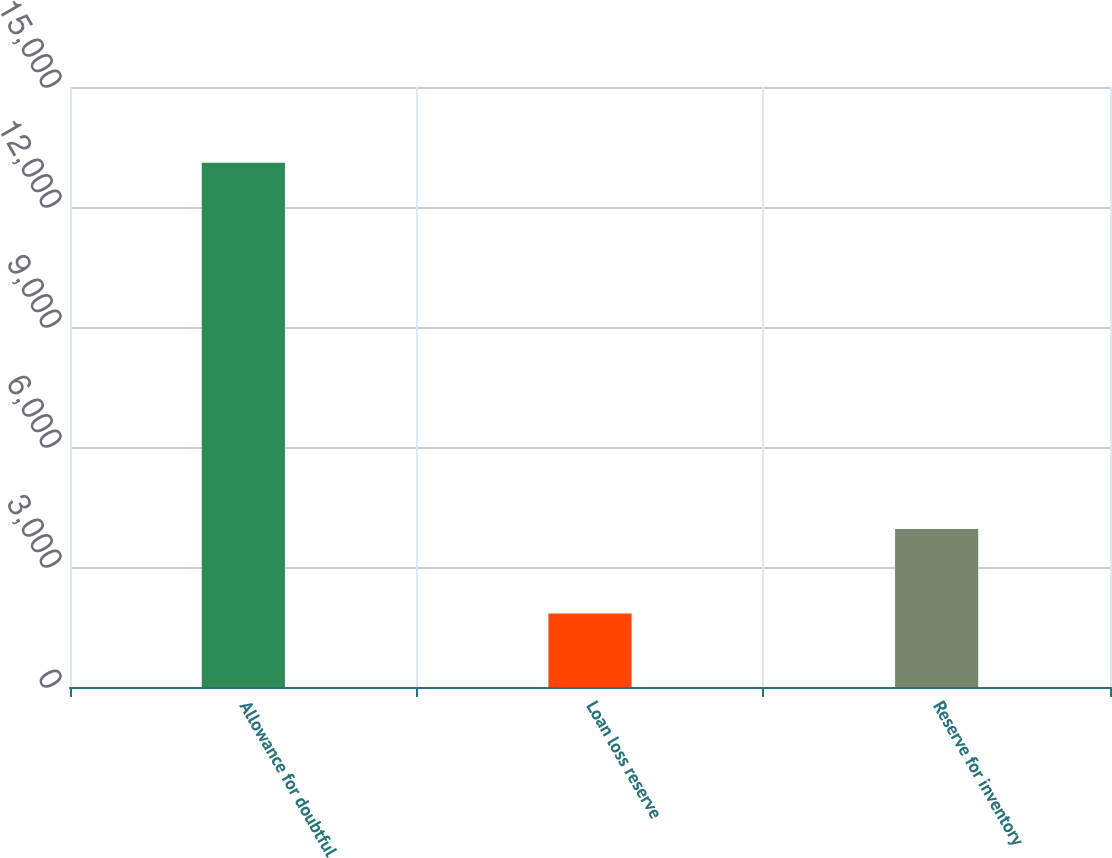Convert chart. <chart><loc_0><loc_0><loc_500><loc_500><bar_chart><fcel>Allowance for doubtful<fcel>Loan loss reserve<fcel>Reserve for inventory<nl><fcel>13109<fcel>1839<fcel>3947<nl></chart> 